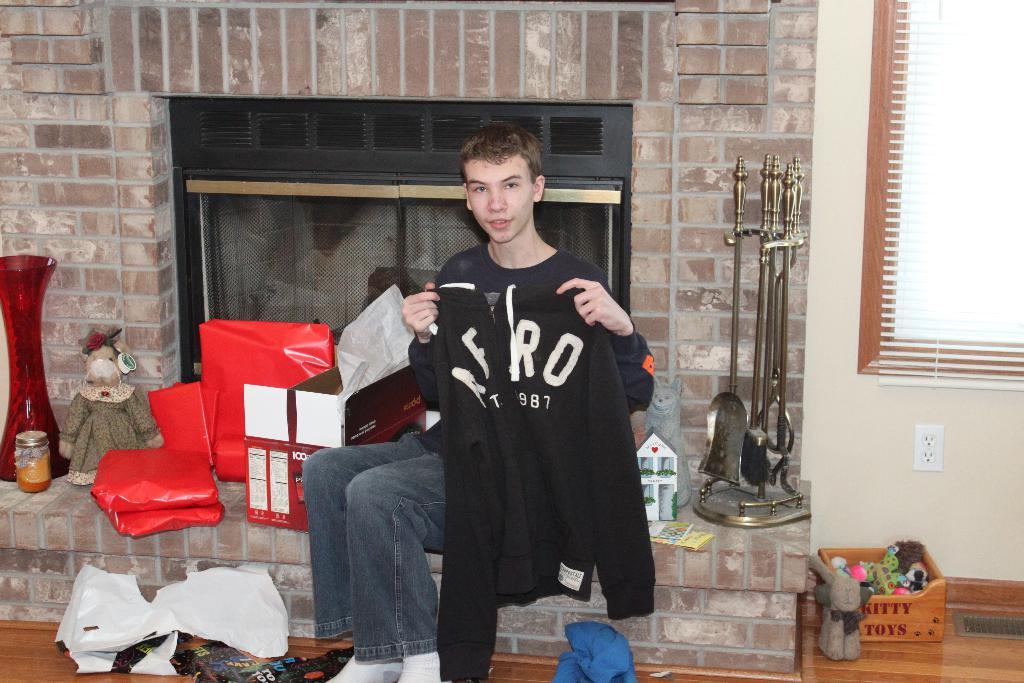What is the shirt brand?
Your answer should be compact. Aero. What three numbers can be see on the shirt?
Keep it short and to the point. 987. 